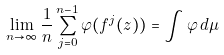<formula> <loc_0><loc_0><loc_500><loc_500>\lim _ { n \to \infty } \frac { 1 } { n } \sum _ { j = 0 } ^ { n - 1 } \varphi ( f ^ { j } ( z ) ) = \int \varphi \, d \mu</formula> 